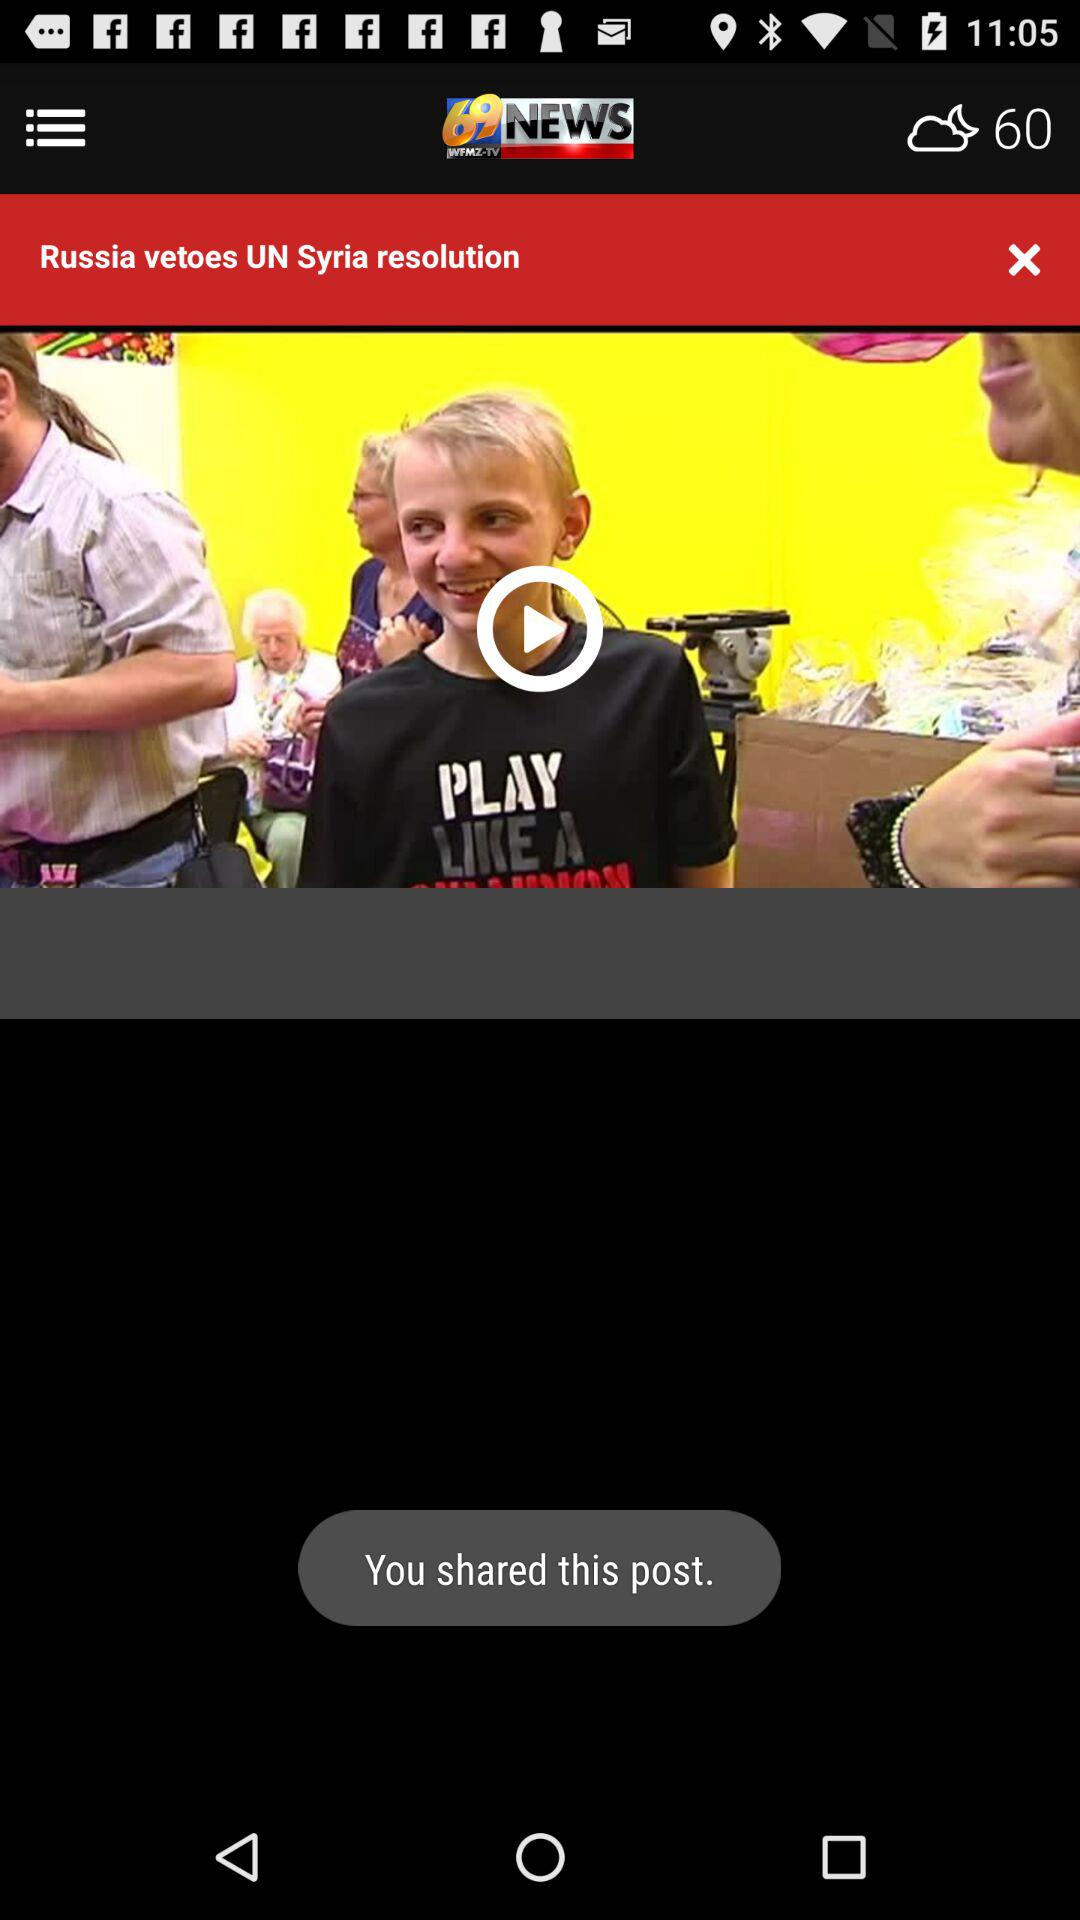What's the temperature? The temperature is 60 degrees. 